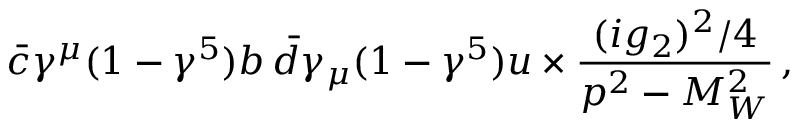Convert formula to latex. <formula><loc_0><loc_0><loc_500><loc_500>\bar { c } \gamma ^ { \mu } ( 1 - \gamma ^ { 5 } ) b \, \bar { d } \gamma _ { \mu } ( 1 - \gamma ^ { 5 } ) u \times { \frac { ( i g _ { 2 } ) ^ { 2 } / 4 } { p ^ { 2 } - M _ { W } ^ { 2 } } } \, ,</formula> 